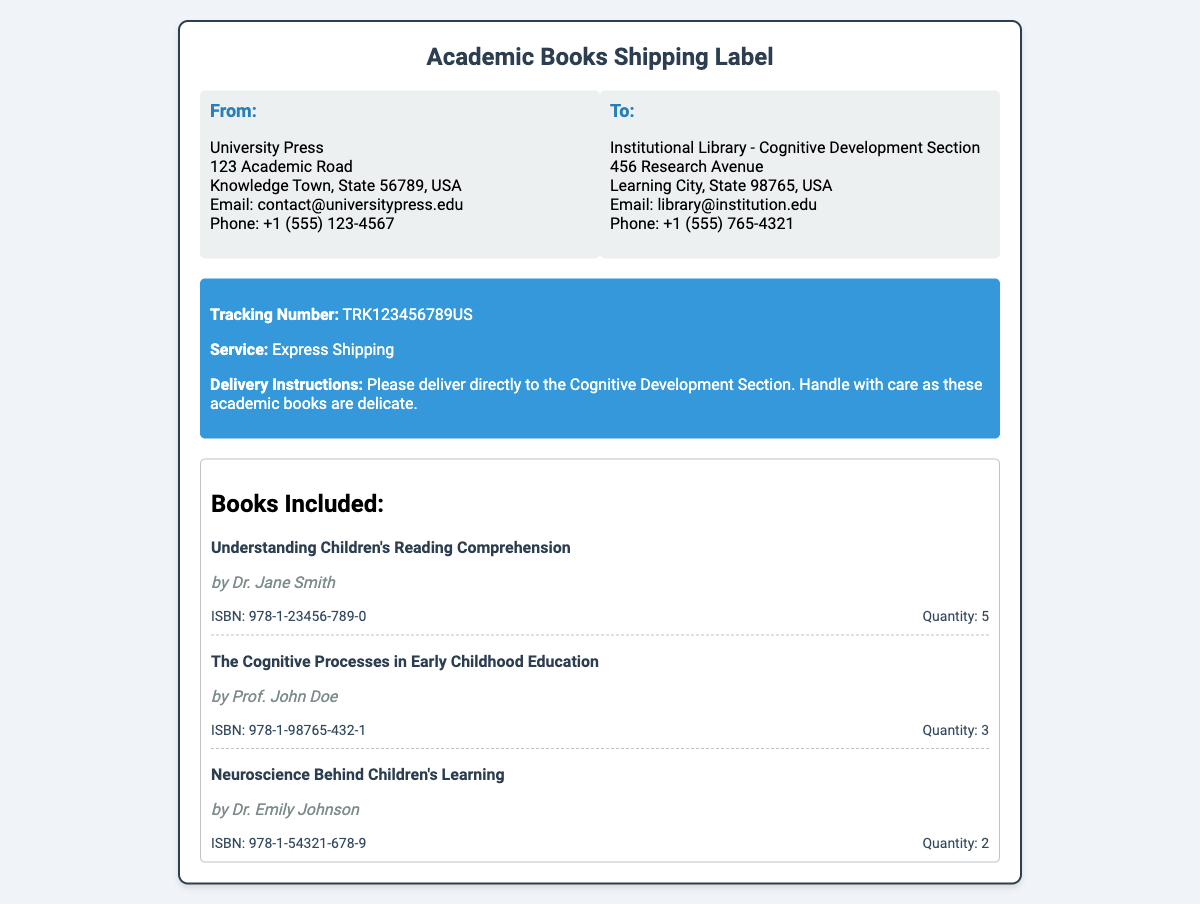What is the tracking number? The tracking number is explicitly mentioned in the shipment information section of the document.
Answer: TRK123456789US How many copies of "Understanding Children's Reading Comprehension" are included? The quantity of this book is stated next to its title in the books section.
Answer: 5 Who is the author of "Neuroscience Behind Children's Learning"? The author is listed beneath the book title in the documents book section.
Answer: Dr. Emily Johnson What delivery instructions are provided? The document specifies the delivery instructions to ensure proper handling.
Answer: Please deliver directly to the Cognitive Development Section. Handle with care as these academic books are delicate How many books are listed in total? This can be determined by counting the individual books in the books section of the document.
Answer: 3 What is the email address of the sender? The email address can be found in the 'From' address section of the shipping label.
Answer: contact@universitypress.edu What service is used for shipment? The type of shipping service is specified in the shipment information section.
Answer: Express Shipping What is the ISBN number of "The Cognitive Processes in Early Childhood Education"? This information is provided next to the book title in the books section.
Answer: 978-1-98765-432-1 